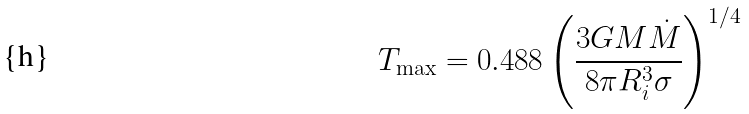Convert formula to latex. <formula><loc_0><loc_0><loc_500><loc_500>T _ { \max } = 0 . 4 8 8 \left ( \frac { 3 G M \dot { M } } { 8 \pi R _ { i } ^ { 3 } \sigma } \right ) ^ { 1 / 4 }</formula> 